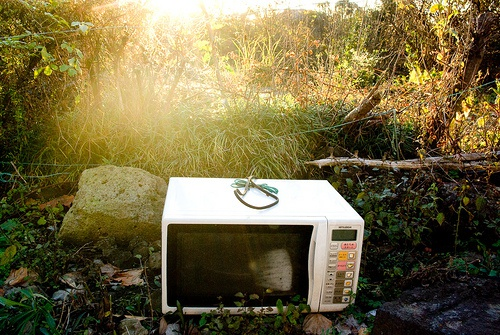Describe the objects in this image and their specific colors. I can see a microwave in olive, black, white, and darkgray tones in this image. 